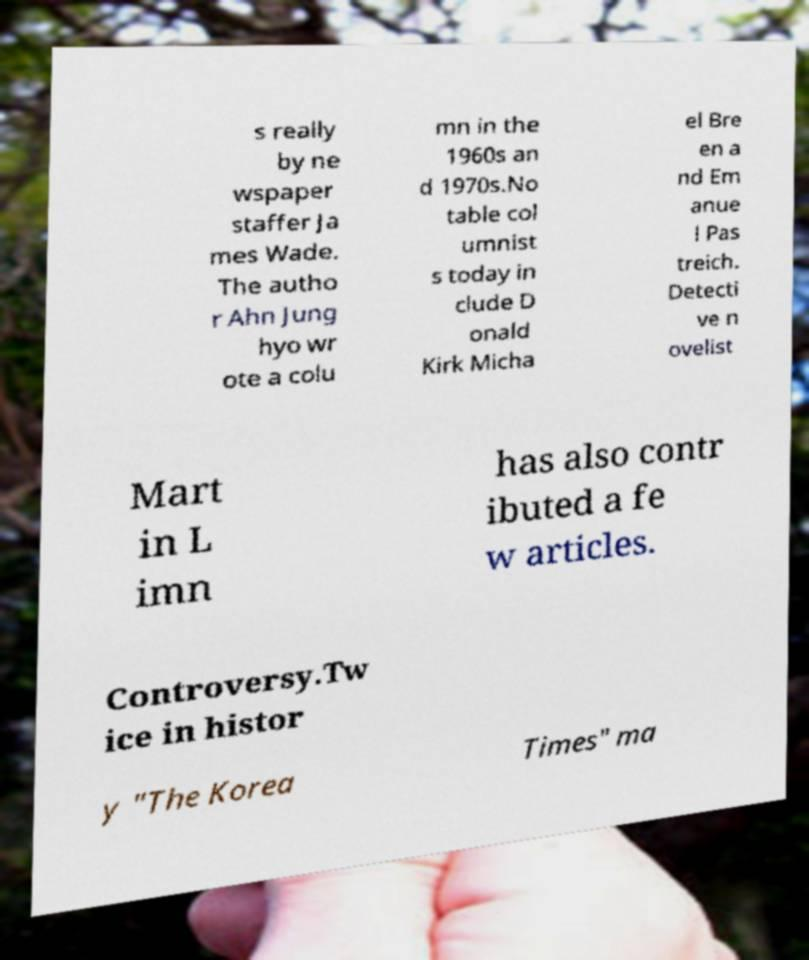What messages or text are displayed in this image? I need them in a readable, typed format. s really by ne wspaper staffer Ja mes Wade. The autho r Ahn Jung hyo wr ote a colu mn in the 1960s an d 1970s.No table col umnist s today in clude D onald Kirk Micha el Bre en a nd Em anue l Pas treich. Detecti ve n ovelist Mart in L imn has also contr ibuted a fe w articles. Controversy.Tw ice in histor y "The Korea Times" ma 